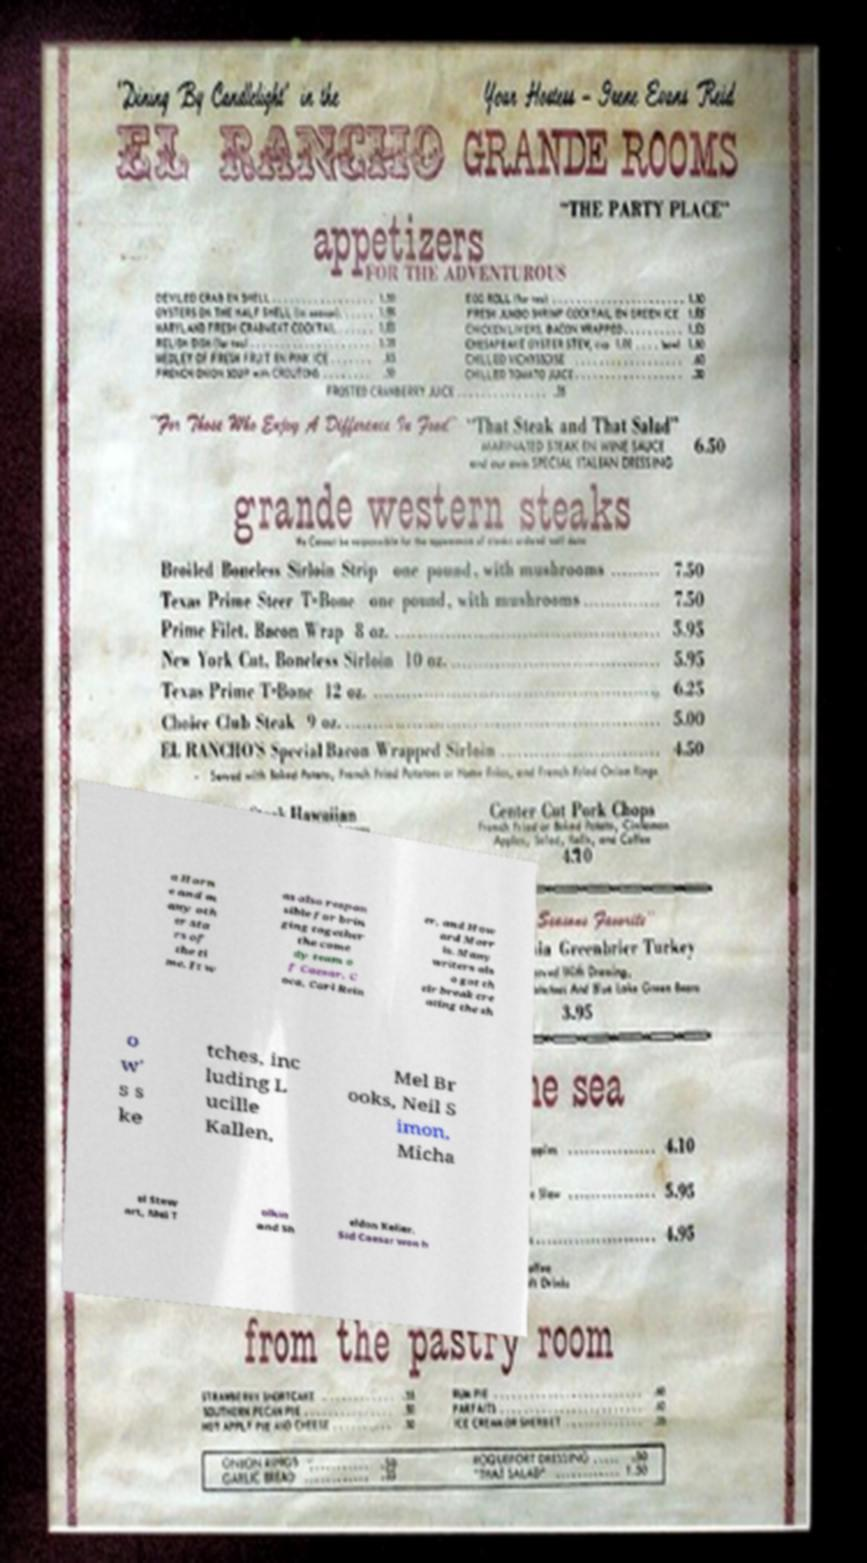There's text embedded in this image that I need extracted. Can you transcribe it verbatim? a Horn e and m any oth er sta rs of the ti me. It w as also respon sible for brin ging together the come dy team o f Caesar, C oca, Carl Rein er, and How ard Morr is. Many writers als o got th eir break cre ating the sh o w' s s ke tches, inc luding L ucille Kallen, Mel Br ooks, Neil S imon, Micha el Stew art, Mel T olkin and Sh eldon Keller. Sid Caesar won h 